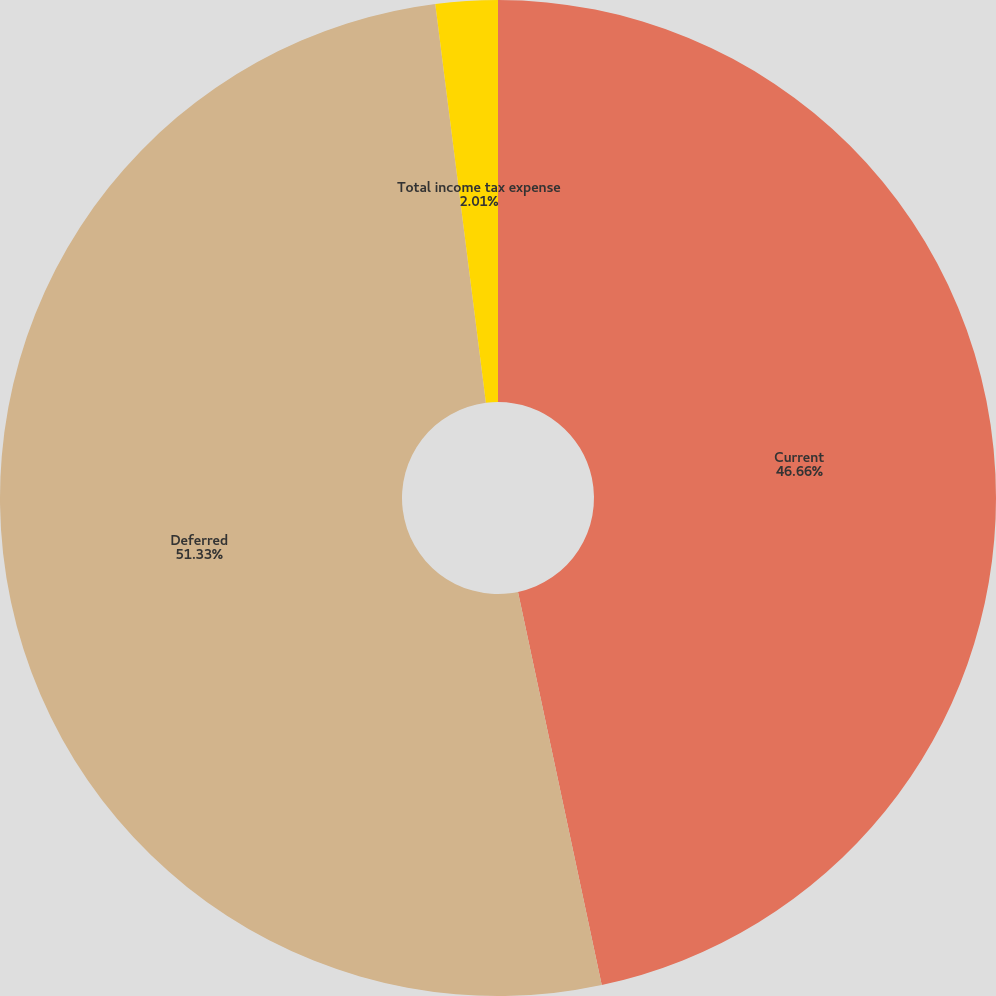Convert chart to OTSL. <chart><loc_0><loc_0><loc_500><loc_500><pie_chart><fcel>Current<fcel>Deferred<fcel>Total income tax expense<nl><fcel>46.66%<fcel>51.33%<fcel>2.01%<nl></chart> 